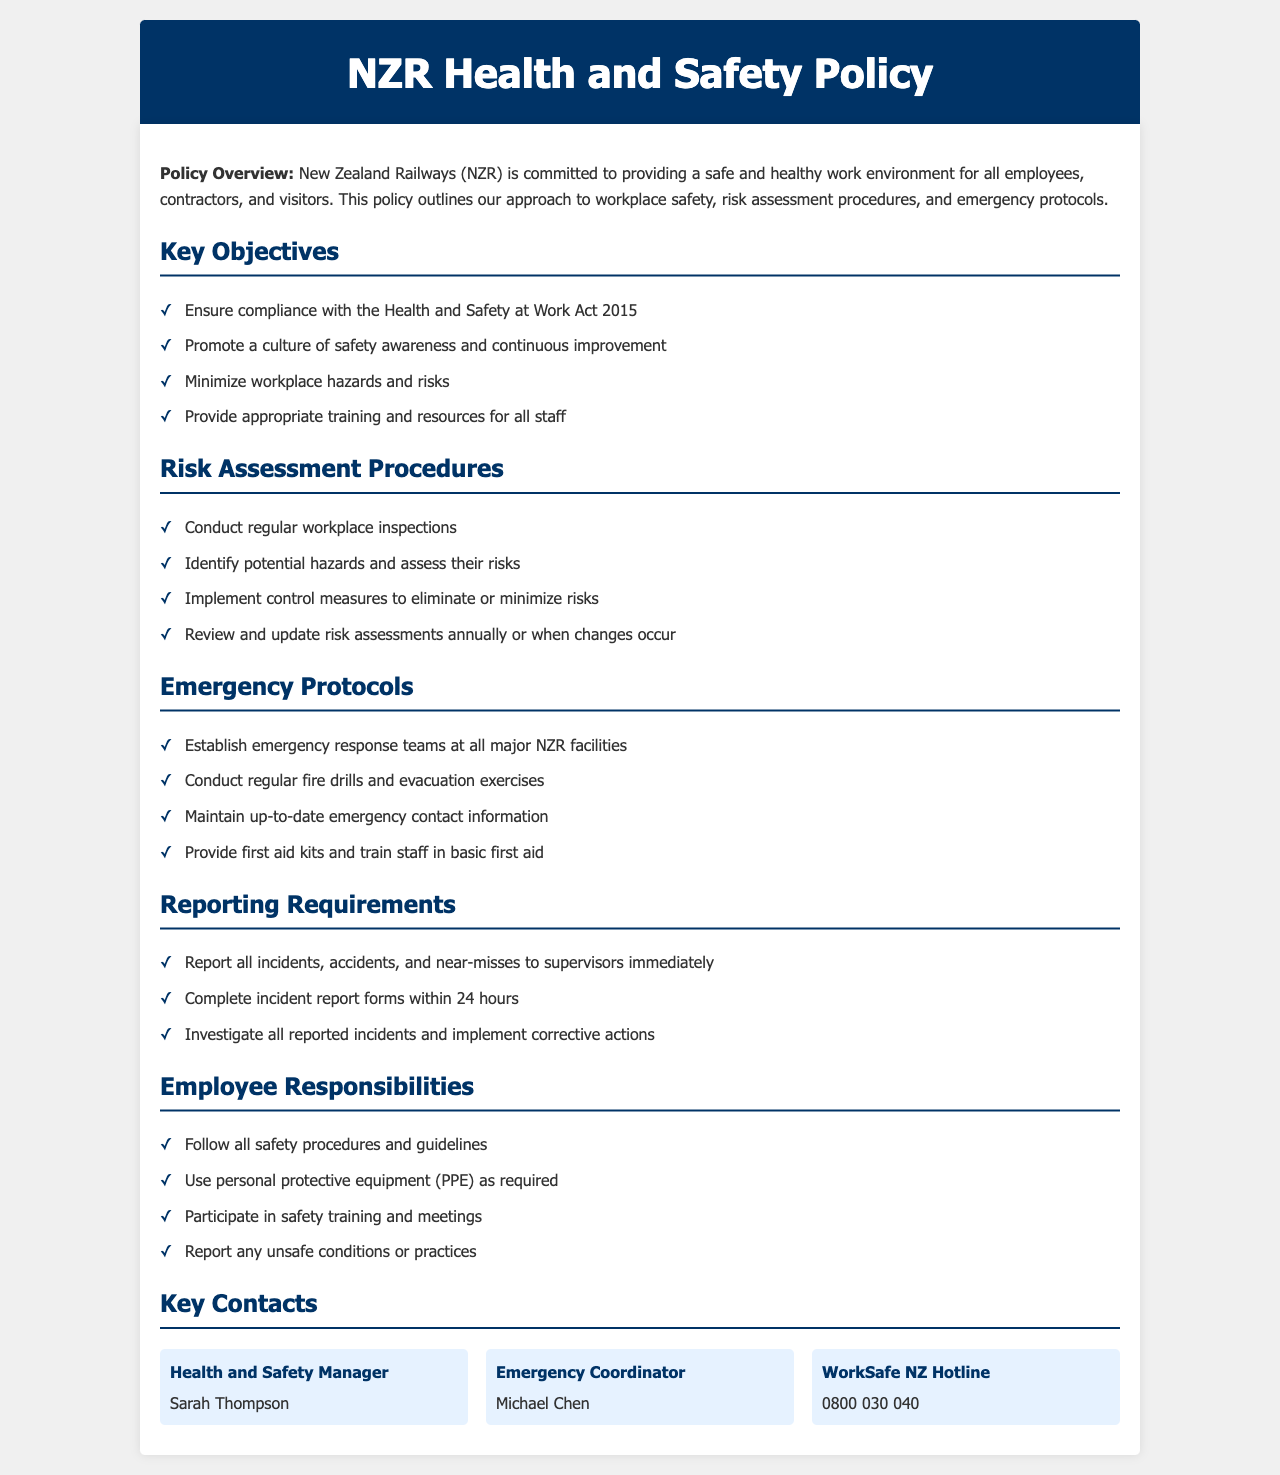What is the primary commitment of NZR? The primary commitment of NZR, as stated in the policy overview, is to provide a safe and healthy work environment for all employees, contractors, and visitors.
Answer: safe and healthy work environment Who is the Health and Safety Manager? The document specifies the name of the Health and Safety Manager as Sarah Thompson.
Answer: Sarah Thompson Which act does NZR ensure compliance with? The policy mentions ensuring compliance with the Health and Safety at Work Act 2015.
Answer: Health and Safety at Work Act 2015 How often are risk assessments reviewed and updated? The document states that risk assessments should be reviewed and updated annually or when changes occur.
Answer: annually or when changes occur What should be done with all incidents, accidents, and near-misses? The policy indicates that all incidents, accidents, and near-misses should be reported to supervisors immediately.
Answer: reported to supervisors immediately How many emergency contact items are listed? The document contains three emergency contact items listed in the Key Contacts section.
Answer: three What is a requirement for employee responsibilities regarding PPE? Employees are required to use personal protective equipment (PPE) as needed according to the document.
Answer: use personal protective equipment (PPE) What is one of the objectives related to workplace hazards? One of the key objectives stated is to minimize workplace hazards and risks.
Answer: minimize workplace hazards and risks What is the phone number for the WorkSafe NZ Hotline? The contact details include the WorkSafe NZ Hotline phone number as 0800 030 040.
Answer: 0800 030 040 